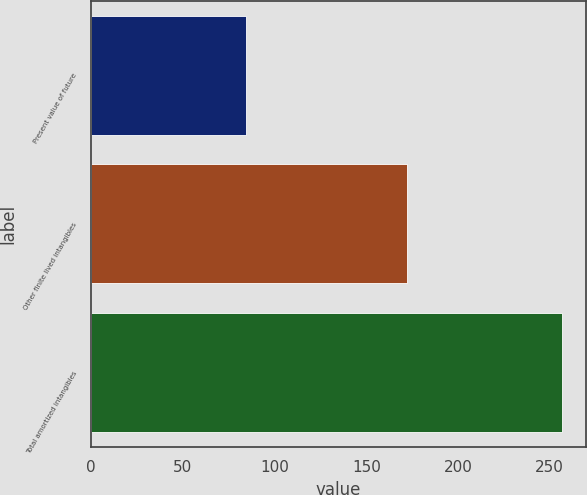Convert chart to OTSL. <chart><loc_0><loc_0><loc_500><loc_500><bar_chart><fcel>Present value of future<fcel>Other finite lived intangibles<fcel>Total amortized intangibles<nl><fcel>84.4<fcel>172.3<fcel>256.7<nl></chart> 